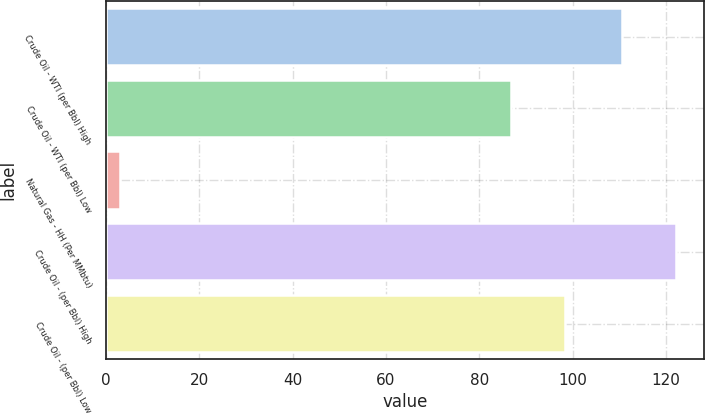Convert chart. <chart><loc_0><loc_0><loc_500><loc_500><bar_chart><fcel>Crude Oil - WTI (per Bbl) High<fcel>Crude Oil - WTI (per Bbl) Low<fcel>Natural Gas - HH (Per MMbtu)<fcel>Crude Oil - (per Bbl) High<fcel>Crude Oil - (per Bbl) Low<nl><fcel>110.53<fcel>86.68<fcel>3.11<fcel>122.11<fcel>98.26<nl></chart> 